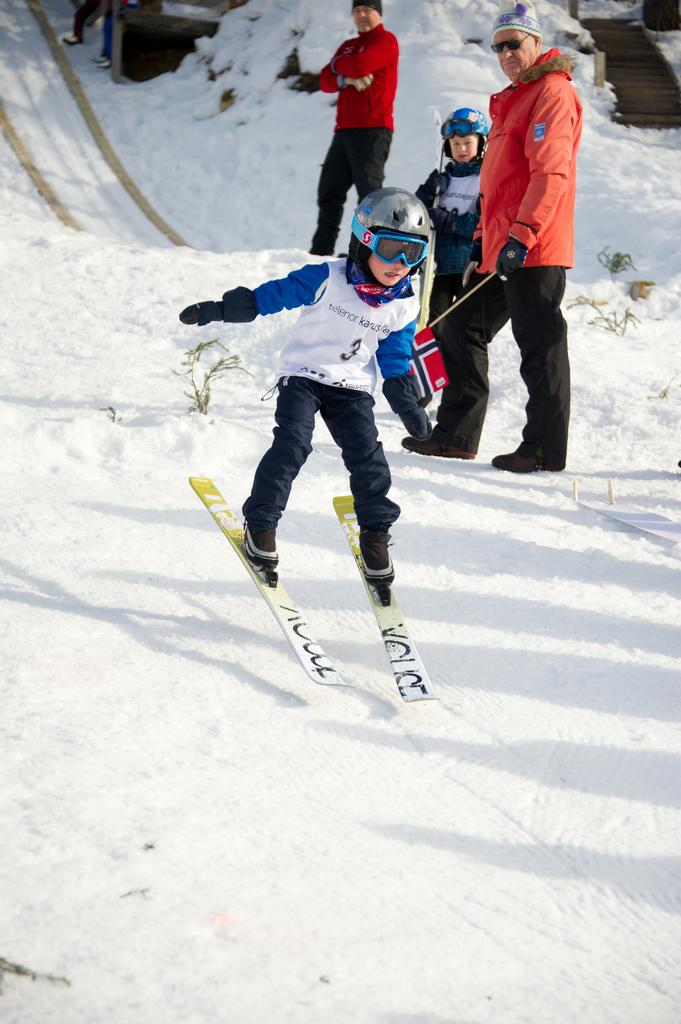Who is the main subject in the image? There is a boy in the center of the image. What protective gear is the boy wearing? The boy is wearing a helmet and goggles. What equipment is the boy using for skiing? The boy is wearing skis. What can be seen in the background of the image? In the background, there is a group of persons standing on the snow. How many monkeys are playing with balls in the image? There are no monkeys or balls present in the image. Are the boy's brothers also wearing skis in the image? The provided facts do not mention any brothers or their presence in the image. 